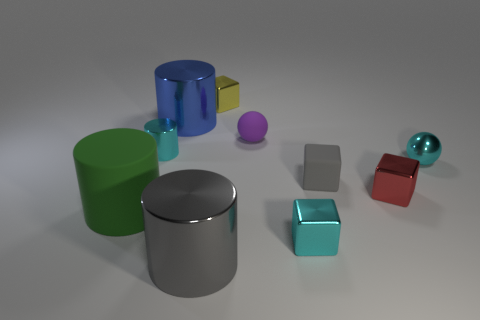Subtract all big gray cylinders. How many cylinders are left? 3 Subtract all gray cubes. How many cubes are left? 3 Subtract 1 blocks. How many blocks are left? 3 Subtract all cylinders. How many objects are left? 6 Subtract 1 gray cylinders. How many objects are left? 9 Subtract all brown cylinders. Subtract all green cubes. How many cylinders are left? 4 Subtract all red metal blocks. Subtract all large cyan rubber cubes. How many objects are left? 9 Add 9 large gray cylinders. How many large gray cylinders are left? 10 Add 8 gray metal cylinders. How many gray metal cylinders exist? 9 